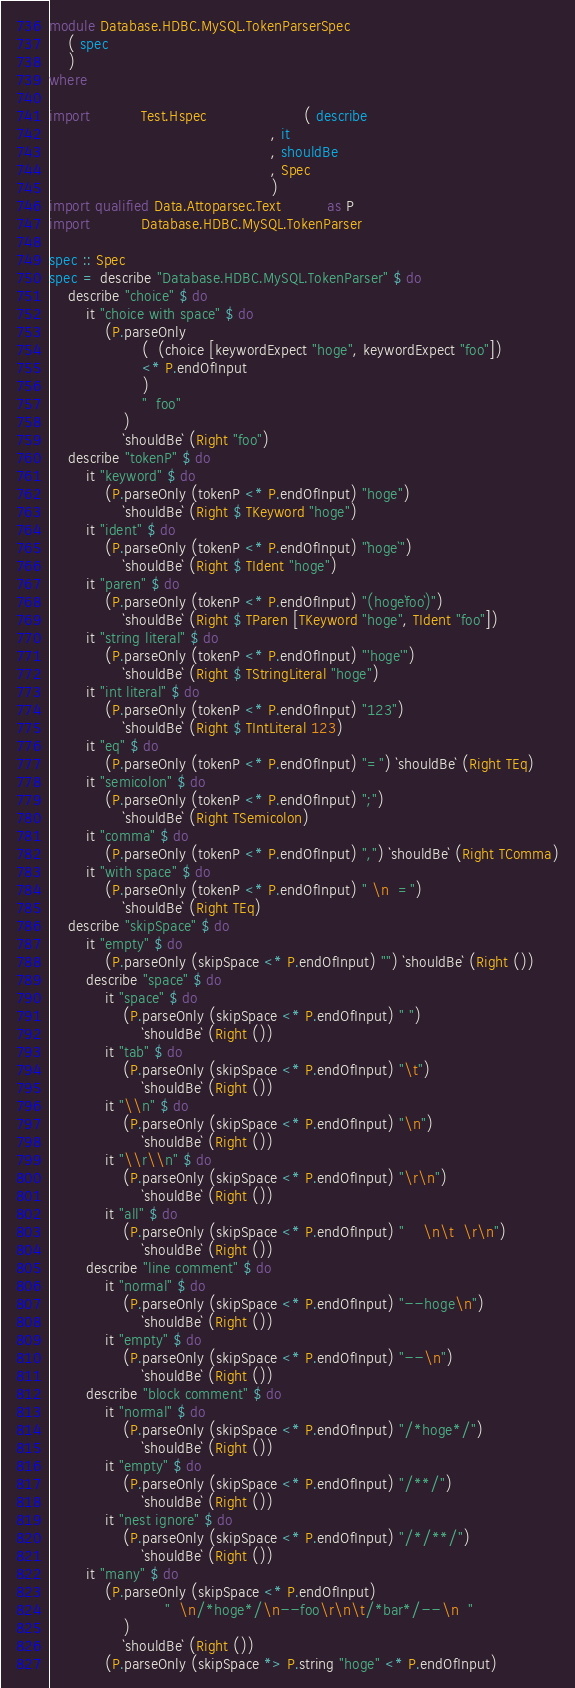<code> <loc_0><loc_0><loc_500><loc_500><_Haskell_>module Database.HDBC.MySQL.TokenParserSpec
    ( spec
    )
where

import           Test.Hspec                     ( describe
                                                , it
                                                , shouldBe
                                                , Spec
                                                )
import qualified Data.Attoparsec.Text          as P
import           Database.HDBC.MySQL.TokenParser

spec :: Spec
spec = describe "Database.HDBC.MySQL.TokenParser" $ do
    describe "choice" $ do
        it "choice with space" $ do
            (P.parseOnly
                    (  (choice [keywordExpect "hoge", keywordExpect "foo"])
                    <* P.endOfInput
                    )
                    "  foo"
                )
                `shouldBe` (Right "foo")
    describe "tokenP" $ do
        it "keyword" $ do
            (P.parseOnly (tokenP <* P.endOfInput) "hoge")
                `shouldBe` (Right $ TKeyword "hoge")
        it "ident" $ do
            (P.parseOnly (tokenP <* P.endOfInput) "`hoge`")
                `shouldBe` (Right $ TIdent "hoge")
        it "paren" $ do
            (P.parseOnly (tokenP <* P.endOfInput) "(hoge`foo`)")
                `shouldBe` (Right $ TParen [TKeyword "hoge", TIdent "foo"])
        it "string literal" $ do
            (P.parseOnly (tokenP <* P.endOfInput) "'hoge'")
                `shouldBe` (Right $ TStringLiteral "hoge")
        it "int literal" $ do
            (P.parseOnly (tokenP <* P.endOfInput) "123")
                `shouldBe` (Right $ TIntLiteral 123)
        it "eq" $ do
            (P.parseOnly (tokenP <* P.endOfInput) "=") `shouldBe` (Right TEq)
        it "semicolon" $ do
            (P.parseOnly (tokenP <* P.endOfInput) ";")
                `shouldBe` (Right TSemicolon)
        it "comma" $ do
            (P.parseOnly (tokenP <* P.endOfInput) ",") `shouldBe` (Right TComma)
        it "with space" $ do
            (P.parseOnly (tokenP <* P.endOfInput) " \n  =")
                `shouldBe` (Right TEq)
    describe "skipSpace" $ do
        it "empty" $ do
            (P.parseOnly (skipSpace <* P.endOfInput) "") `shouldBe` (Right ())
        describe "space" $ do
            it "space" $ do
                (P.parseOnly (skipSpace <* P.endOfInput) " ")
                    `shouldBe` (Right ())
            it "tab" $ do
                (P.parseOnly (skipSpace <* P.endOfInput) "\t")
                    `shouldBe` (Right ())
            it "\\n" $ do
                (P.parseOnly (skipSpace <* P.endOfInput) "\n")
                    `shouldBe` (Right ())
            it "\\r\\n" $ do
                (P.parseOnly (skipSpace <* P.endOfInput) "\r\n")
                    `shouldBe` (Right ())
            it "all" $ do
                (P.parseOnly (skipSpace <* P.endOfInput) "    \n\t  \r\n")
                    `shouldBe` (Right ())
        describe "line comment" $ do
            it "normal" $ do
                (P.parseOnly (skipSpace <* P.endOfInput) "--hoge\n")
                    `shouldBe` (Right ())
            it "empty" $ do
                (P.parseOnly (skipSpace <* P.endOfInput) "--\n")
                    `shouldBe` (Right ())
        describe "block comment" $ do
            it "normal" $ do
                (P.parseOnly (skipSpace <* P.endOfInput) "/*hoge*/")
                    `shouldBe` (Right ())
            it "empty" $ do
                (P.parseOnly (skipSpace <* P.endOfInput) "/**/")
                    `shouldBe` (Right ())
            it "nest ignore" $ do
                (P.parseOnly (skipSpace <* P.endOfInput) "/*/**/")
                    `shouldBe` (Right ())
        it "many" $ do
            (P.parseOnly (skipSpace <* P.endOfInput)
                         "  \n/*hoge*/\n--foo\r\n\t/*bar*/--\n  "
                )
                `shouldBe` (Right ())
            (P.parseOnly (skipSpace *> P.string "hoge" <* P.endOfInput)</code> 